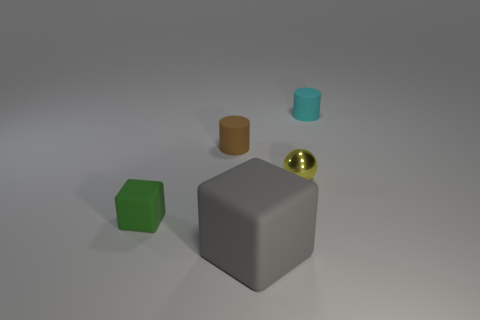Are there any large objects of the same color as the metallic sphere?
Give a very brief answer. No. The rubber object on the left side of the matte cylinder that is in front of the tiny matte thing that is right of the tiny yellow shiny ball is what color?
Give a very brief answer. Green. Does the small green cube have the same material as the object that is on the right side of the small metal ball?
Your answer should be compact. Yes. What is the green object made of?
Keep it short and to the point. Rubber. How many other things are made of the same material as the ball?
Provide a short and direct response. 0. What shape is the thing that is on the right side of the large gray rubber cube and on the left side of the small cyan rubber cylinder?
Offer a very short reply. Sphere. What color is the cube that is the same material as the tiny green thing?
Provide a short and direct response. Gray. Are there the same number of tiny cyan rubber cylinders that are to the left of the tiny cyan cylinder and metallic things?
Give a very brief answer. No. What shape is the cyan thing that is the same size as the yellow object?
Make the answer very short. Cylinder. What number of other objects are the same shape as the yellow shiny object?
Provide a succinct answer. 0. 